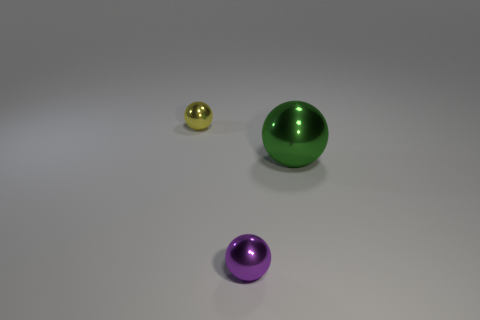Are there any other things that have the same size as the green ball?
Offer a terse response. No. Are there more large green balls than large green matte objects?
Your answer should be very brief. Yes. There is a tiny metallic object behind the big sphere; is its shape the same as the tiny purple object?
Keep it short and to the point. Yes. Is the number of cyan cubes less than the number of tiny metal balls?
Offer a very short reply. Yes. Is the number of tiny purple things in front of the purple ball less than the number of large green metallic spheres?
Keep it short and to the point. Yes. What number of large cyan rubber cylinders are there?
Keep it short and to the point. 0. What is the shape of the tiny object that is in front of the tiny metal ball that is behind the large thing?
Make the answer very short. Sphere. How many things are left of the big green shiny object?
Offer a very short reply. 2. Do the yellow thing and the tiny ball right of the tiny yellow object have the same material?
Ensure brevity in your answer.  Yes. Are there any yellow things of the same size as the purple metallic thing?
Ensure brevity in your answer.  Yes. 